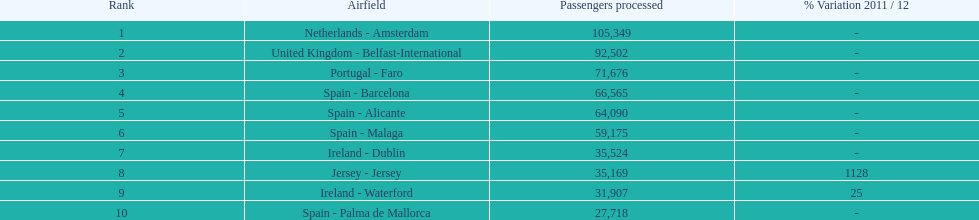How many passengers are going to or coming from spain? 217,548. 